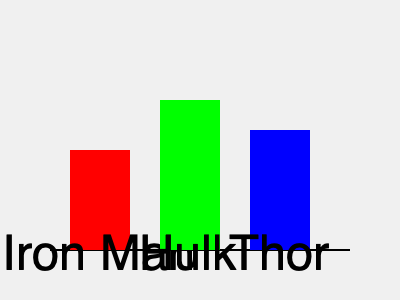Yo, check out this sick superhero lineup! Which one of these dudes is the shortest? It's like, totally important for saving the world and stuff, right? Alright, let's break this down, bro:

1. We've got three superheroes in this pic: Iron Man, Hulk, and Thor.
2. The taller the rectangle, the taller the hero. Simple, right?
3. Iron Man's rectangle goes from 150 to 250 on the y-axis, so he's 100 units tall.
4. Hulk's rectangle goes from 100 to 250, making him 150 units tall. Dude's huge!
5. Thor's rectangle goes from 130 to 250, so he's 120 units tall.
6. If we rank them from shortest to tallest, it's like:
   Iron Man (100) < Thor (120) < Hulk (150)

So, Iron Man's the shorty in this superhero squad. But hey, size doesn't matter when you're saving the world, am I right?
Answer: Iron Man 